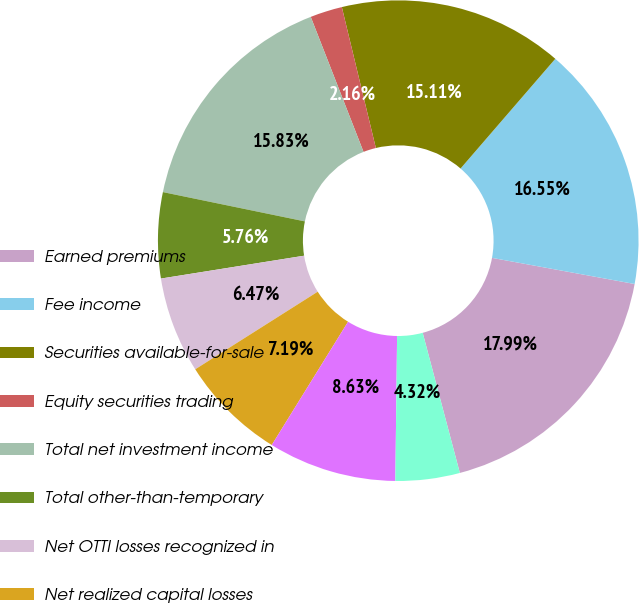Convert chart. <chart><loc_0><loc_0><loc_500><loc_500><pie_chart><fcel>Earned premiums<fcel>Fee income<fcel>Securities available-for-sale<fcel>Equity securities trading<fcel>Total net investment income<fcel>Total other-than-temporary<fcel>Net OTTI losses recognized in<fcel>Net realized capital losses<fcel>Total net realized capital<fcel>Other revenues<nl><fcel>17.99%<fcel>16.55%<fcel>15.11%<fcel>2.16%<fcel>15.83%<fcel>5.76%<fcel>6.47%<fcel>7.19%<fcel>8.63%<fcel>4.32%<nl></chart> 